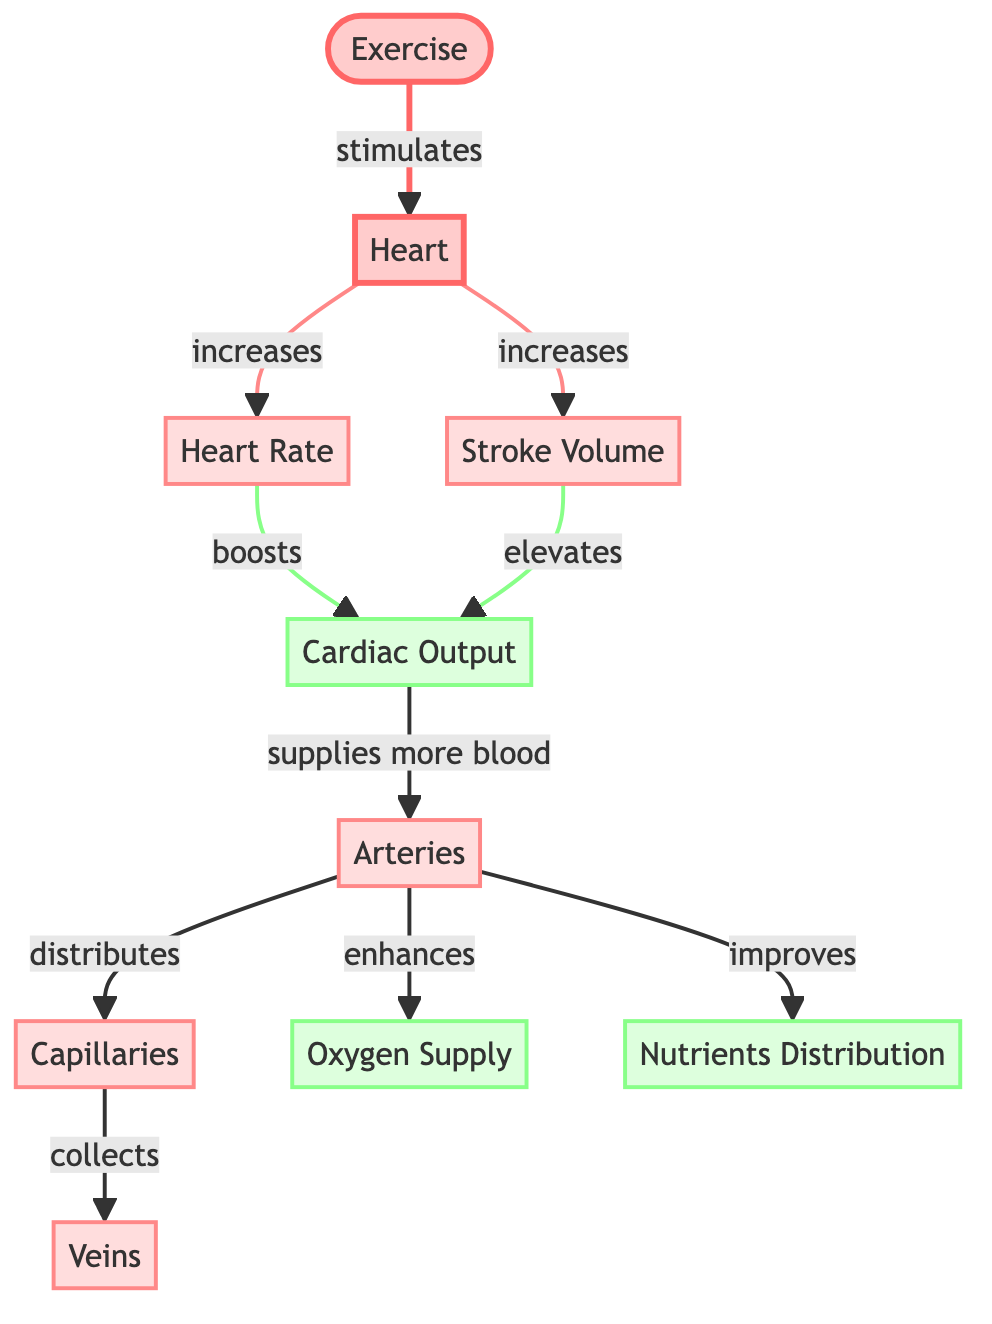What effects does exercise have on the heart? The diagram indicates that exercise stimulates the heart, leading to increases in heart rate and stroke volume.
Answer: Increases in heart rate and stroke volume What is the role of arteries in this diagram? According to the diagram, arteries receive blood from the heart, distribute it to capillaries, enhance oxygen supply, and improve nutrient distribution.
Answer: Distributes blood, enhances oxygen supply, improves nutrient distribution How many nodes are in the diagram? By counting the visual elements listed in the diagram, there are a total of 10 nodes representing different components of cardiovascular function.
Answer: 10 nodes What boosts cardiac output in the diagram? The diagram specifies that heart rate and stroke volume boost cardiac output; both are directly linked to the heart.
Answer: Heart rate and stroke volume What specifically collects blood from capillaries? The diagram indicates that veins are responsible for collecting blood from capillaries after it has been distributed.
Answer: Veins Which component directly stimulates the heart? The diagram shows that exercise directly stimulates the heart, initiating the processes portrayed in the diagram.
Answer: Exercise How does stroke volume affect cardiac output? The diagram demonstrates that stroke volume elevates cardiac output, indicating a positive relationship between the two components.
Answer: Elevates cardiac output What does increased cardiac output supply more of to arteries? The diagram indicates that increased cardiac output supplies more blood to the arteries.
Answer: More blood What enhances oxygen supply according to the diagram? The diagram shows that arteries enhance the oxygen supply as part of the overall flow of blood and nutrients.
Answer: Arteries 